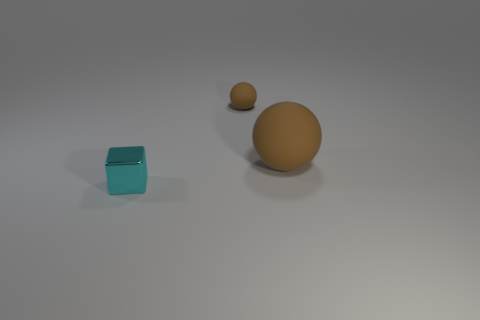How many brown rubber balls are behind the small metal cube?
Give a very brief answer. 2. Is the number of tiny rubber spheres that are behind the tiny cyan metal thing greater than the number of cyan spheres?
Offer a very short reply. Yes. There is a small object that is the same material as the large thing; what is its shape?
Your response must be concise. Sphere. The small object that is to the left of the rubber object that is behind the big object is what color?
Your answer should be very brief. Cyan. Is the shape of the small matte thing the same as the tiny cyan metallic object?
Provide a short and direct response. No. What material is the other object that is the same shape as the big matte object?
Your answer should be compact. Rubber. There is a cyan metal block that is in front of the small sphere that is behind the big brown matte ball; are there any large things that are behind it?
Your response must be concise. Yes. Do the small cyan metal object and the object behind the large brown rubber ball have the same shape?
Keep it short and to the point. No. Are there any other things of the same color as the metal thing?
Your answer should be compact. No. Does the rubber thing that is to the left of the large matte ball have the same color as the rubber ball that is to the right of the small brown sphere?
Make the answer very short. Yes. 